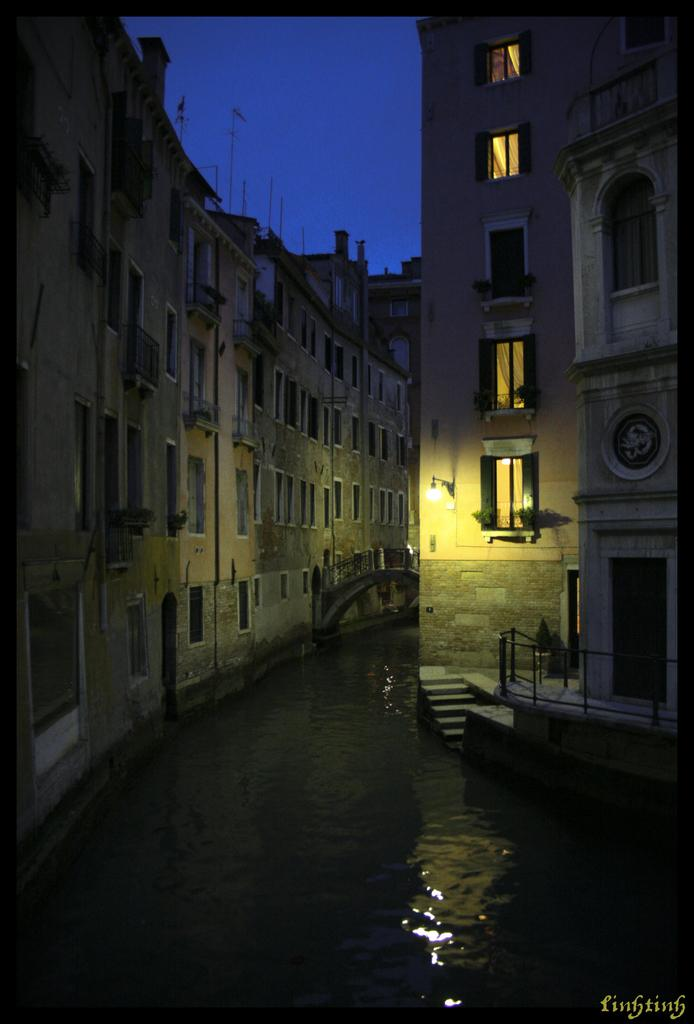What type of structures are visible in the image? There are buildings in the image. What can be seen in the center of the image? There is water in the center of the image. Can you describe a specific feature of one of the buildings? There is a light hanging on the right side of a building. How does the lawyer feel about the aftermath of the throat surgery in the image? There is no lawyer, throat surgery, or any indication of a medical procedure in the image. 